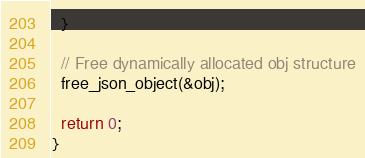<code> <loc_0><loc_0><loc_500><loc_500><_C++_>
  }

  // Free dynamically allocated obj structure
  free_json_object(&obj);
  
  return 0;
}

</code> 